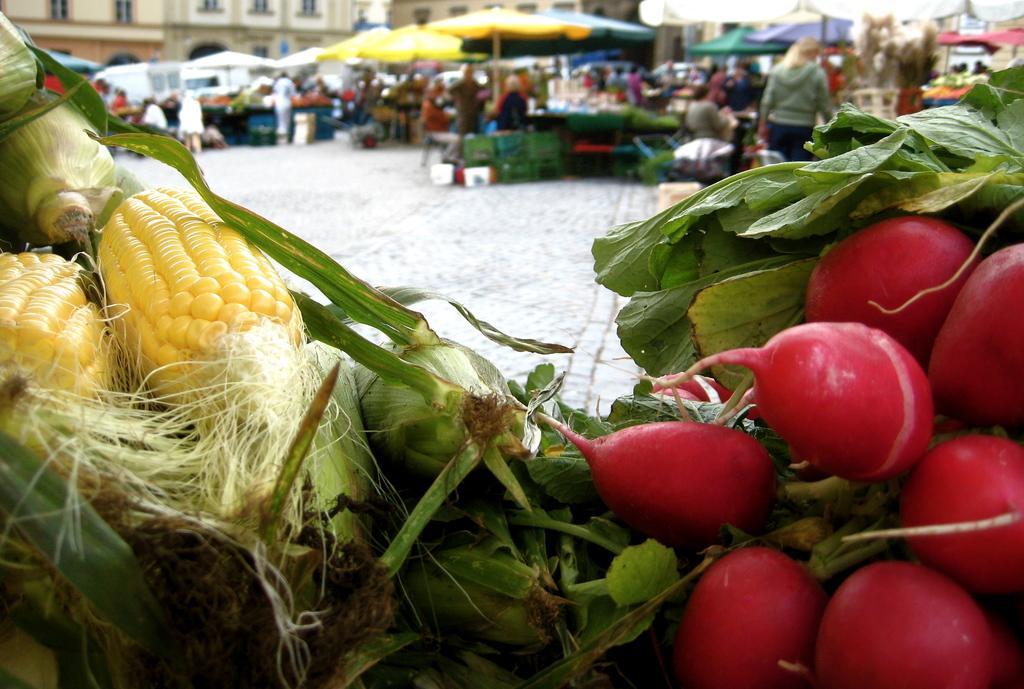Could you give a brief overview of what you see in this image? In this image we can see two types of vegetables. In the background we can see some people standing under the tents. Image also consists of buildings. Ground is also visible. 